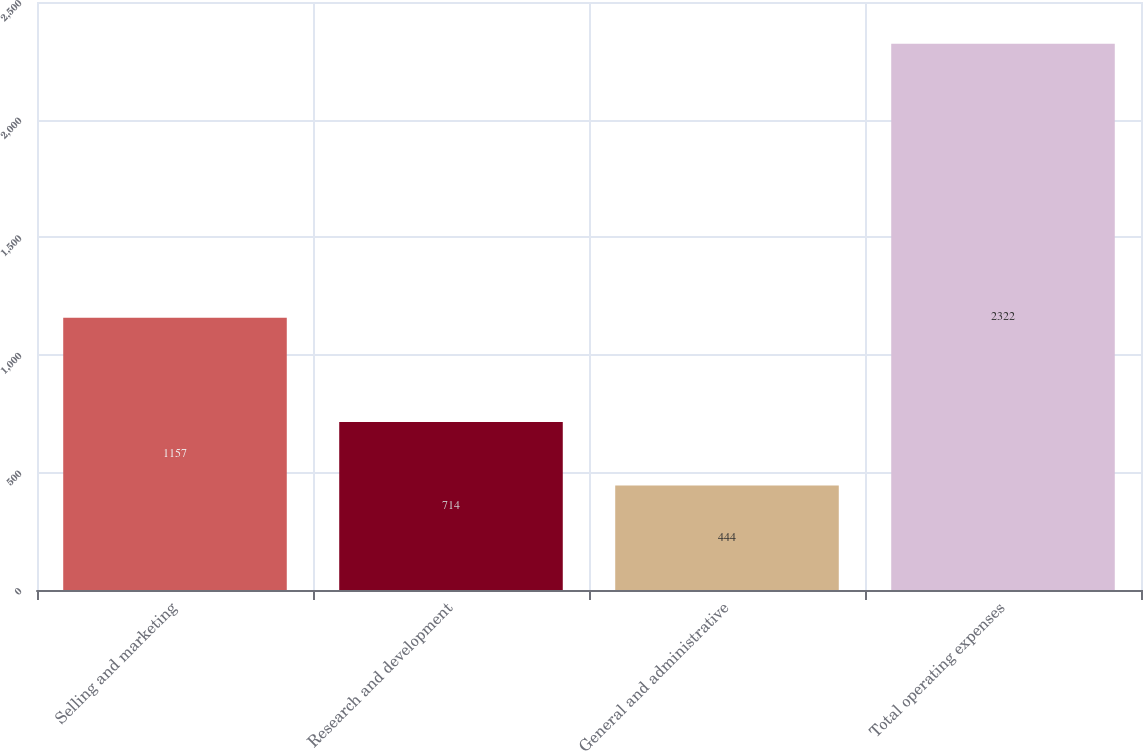Convert chart to OTSL. <chart><loc_0><loc_0><loc_500><loc_500><bar_chart><fcel>Selling and marketing<fcel>Research and development<fcel>General and administrative<fcel>Total operating expenses<nl><fcel>1157<fcel>714<fcel>444<fcel>2322<nl></chart> 